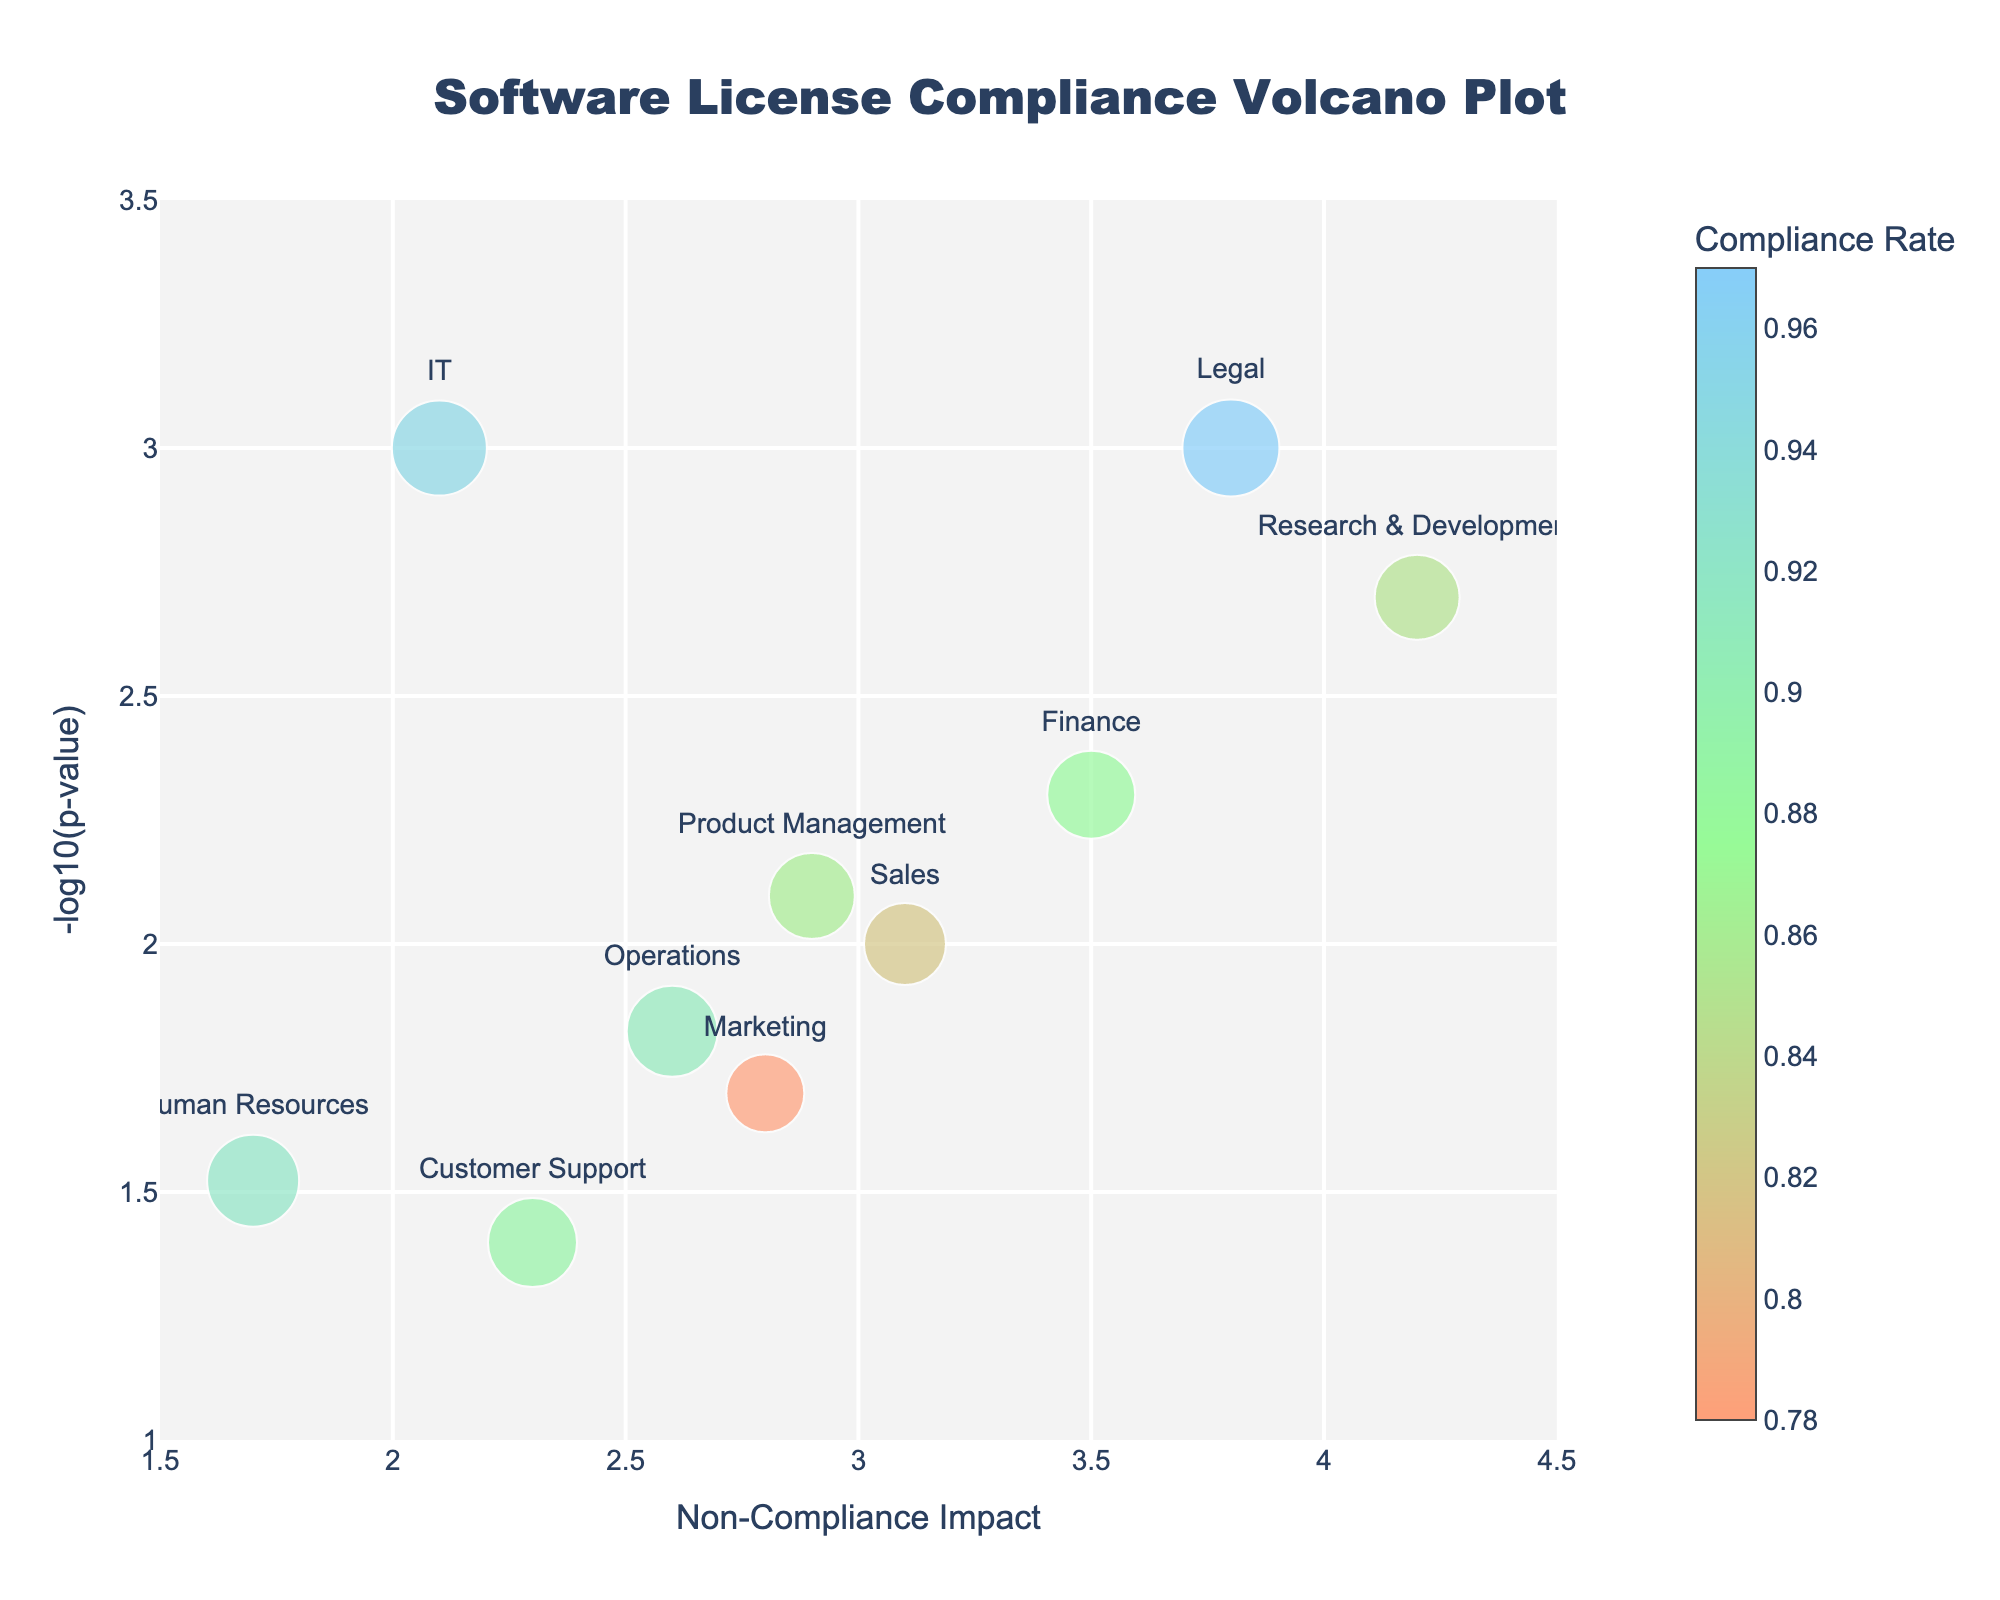What is the title of the plot? The title is typically found at the top of the plot and often contains large and bold text for emphasis. The plot's title is "Software License Compliance Volcano Plot."
Answer: "Software License Compliance Volcano Plot" Which department has the highest compliance rate? To determine the highest compliance rate, look for the largest circle on the plot. The department with the highest compliance rate is represented by the Legal department with a compliance rate of 0.97.
Answer: Legal What is the significance of the p-value for the IT department? The y-axis represents the -log10(p-value) for each department. Look for the y-coordinate of the IT department's point, represented by its label near the top center. The p-value for IT is 0.001, and -log10(0.001) is 3.
Answer: 3 How many departments have a non-compliance impact greater than 3.0? Identify the points on the x-axis that are located to the right of the value 3.0. There are points for Finance, Marketing, Research & Development, Legal, and Sales. Counting these departments gives 5.
Answer: 5 Which department has the lowest non-compliance impact? To find the department with the lowest non-compliance impact, look for the point closest to the left side of the x-axis with the smallest x-coordinate. Human Resources has a non-compliance impact of 1.7.
Answer: Human Resources What are the compliance rates of departments with a p-value less than 0.01? Identify departments whose points are above the -log10(p-value) threshold of 2, corresponding to a p-value of 0.01. These departments are IT, Finance, Research & Development, Legal, and Product Management. Their compliance rates are 0.95, 0.88, 0.85, 0.97, and 0.86, respectively.
Answer: 0.95, 0.88, 0.85, 0.97, 0.86 Which department has the most significant non-compliance impact, and what is its compliance rate? The most significant non-compliance impact is seen in the department farthest to the right on the x-axis. Research & Development has the highest non-compliance impact of 4.2, with a compliance rate of 0.85.
Answer: Research & Development, 0.85 Is there any department with a non-compliance impact smaller than 2 but with a -log10(p-value) higher than 2? Check for points that lie to the left of the x-axis value 2 and above the y-axis value 2. There are no such departments fitting these criteria.
Answer: No 